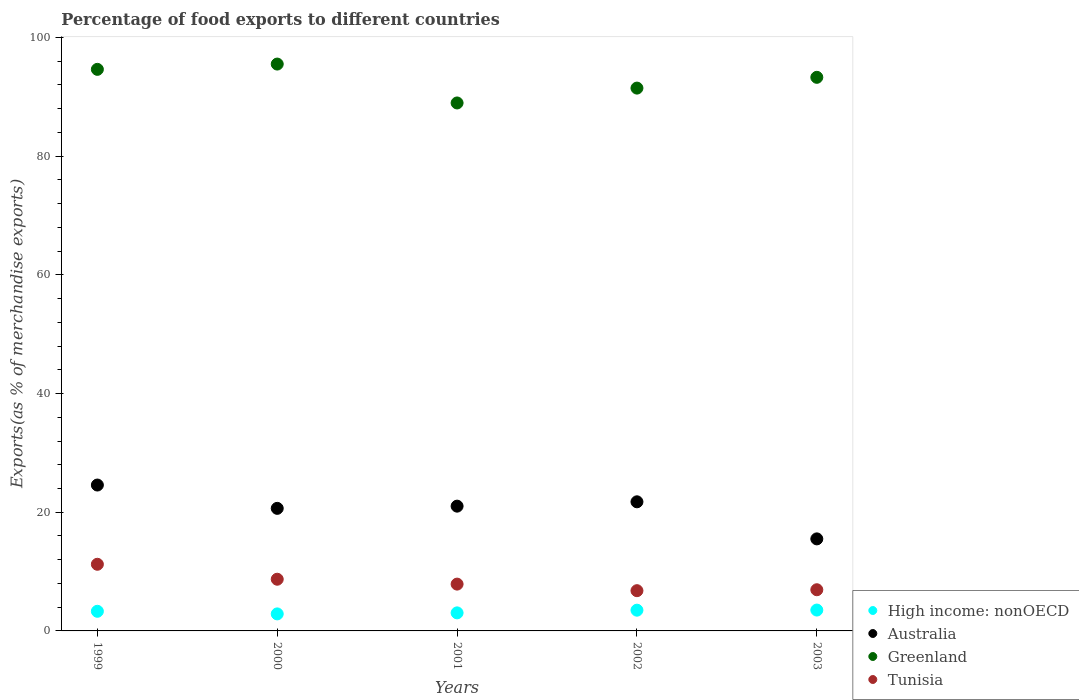How many different coloured dotlines are there?
Your response must be concise. 4. What is the percentage of exports to different countries in Australia in 2003?
Your response must be concise. 15.51. Across all years, what is the maximum percentage of exports to different countries in High income: nonOECD?
Keep it short and to the point. 3.52. Across all years, what is the minimum percentage of exports to different countries in Tunisia?
Ensure brevity in your answer.  6.78. In which year was the percentage of exports to different countries in Greenland maximum?
Provide a short and direct response. 2000. In which year was the percentage of exports to different countries in Tunisia minimum?
Keep it short and to the point. 2002. What is the total percentage of exports to different countries in Tunisia in the graph?
Keep it short and to the point. 41.55. What is the difference between the percentage of exports to different countries in Tunisia in 2000 and that in 2001?
Keep it short and to the point. 0.82. What is the difference between the percentage of exports to different countries in Tunisia in 2001 and the percentage of exports to different countries in Greenland in 2000?
Offer a terse response. -87.63. What is the average percentage of exports to different countries in Australia per year?
Make the answer very short. 20.7. In the year 1999, what is the difference between the percentage of exports to different countries in Greenland and percentage of exports to different countries in High income: nonOECD?
Make the answer very short. 91.31. What is the ratio of the percentage of exports to different countries in High income: nonOECD in 2001 to that in 2003?
Offer a terse response. 0.87. What is the difference between the highest and the second highest percentage of exports to different countries in Tunisia?
Keep it short and to the point. 2.52. What is the difference between the highest and the lowest percentage of exports to different countries in Greenland?
Offer a terse response. 6.55. In how many years, is the percentage of exports to different countries in High income: nonOECD greater than the average percentage of exports to different countries in High income: nonOECD taken over all years?
Make the answer very short. 3. Is it the case that in every year, the sum of the percentage of exports to different countries in Tunisia and percentage of exports to different countries in Greenland  is greater than the sum of percentage of exports to different countries in High income: nonOECD and percentage of exports to different countries in Australia?
Your response must be concise. Yes. Is it the case that in every year, the sum of the percentage of exports to different countries in Tunisia and percentage of exports to different countries in Greenland  is greater than the percentage of exports to different countries in Australia?
Your answer should be compact. Yes. Is the percentage of exports to different countries in High income: nonOECD strictly less than the percentage of exports to different countries in Australia over the years?
Offer a very short reply. Yes. How many years are there in the graph?
Offer a terse response. 5. Are the values on the major ticks of Y-axis written in scientific E-notation?
Ensure brevity in your answer.  No. Does the graph contain grids?
Provide a short and direct response. No. Where does the legend appear in the graph?
Provide a succinct answer. Bottom right. What is the title of the graph?
Your answer should be compact. Percentage of food exports to different countries. Does "Palau" appear as one of the legend labels in the graph?
Your answer should be compact. No. What is the label or title of the X-axis?
Your answer should be very brief. Years. What is the label or title of the Y-axis?
Offer a terse response. Exports(as % of merchandise exports). What is the Exports(as % of merchandise exports) in High income: nonOECD in 1999?
Give a very brief answer. 3.31. What is the Exports(as % of merchandise exports) of Australia in 1999?
Provide a short and direct response. 24.58. What is the Exports(as % of merchandise exports) in Greenland in 1999?
Provide a succinct answer. 94.62. What is the Exports(as % of merchandise exports) in Tunisia in 1999?
Ensure brevity in your answer.  11.23. What is the Exports(as % of merchandise exports) of High income: nonOECD in 2000?
Your answer should be compact. 2.87. What is the Exports(as % of merchandise exports) in Australia in 2000?
Your answer should be very brief. 20.65. What is the Exports(as % of merchandise exports) in Greenland in 2000?
Keep it short and to the point. 95.51. What is the Exports(as % of merchandise exports) of Tunisia in 2000?
Give a very brief answer. 8.71. What is the Exports(as % of merchandise exports) of High income: nonOECD in 2001?
Offer a very short reply. 3.04. What is the Exports(as % of merchandise exports) of Australia in 2001?
Your answer should be very brief. 21.02. What is the Exports(as % of merchandise exports) in Greenland in 2001?
Provide a succinct answer. 88.96. What is the Exports(as % of merchandise exports) in Tunisia in 2001?
Your response must be concise. 7.89. What is the Exports(as % of merchandise exports) in High income: nonOECD in 2002?
Provide a short and direct response. 3.49. What is the Exports(as % of merchandise exports) in Australia in 2002?
Your answer should be very brief. 21.76. What is the Exports(as % of merchandise exports) of Greenland in 2002?
Make the answer very short. 91.46. What is the Exports(as % of merchandise exports) of Tunisia in 2002?
Ensure brevity in your answer.  6.78. What is the Exports(as % of merchandise exports) in High income: nonOECD in 2003?
Give a very brief answer. 3.52. What is the Exports(as % of merchandise exports) of Australia in 2003?
Provide a succinct answer. 15.51. What is the Exports(as % of merchandise exports) of Greenland in 2003?
Give a very brief answer. 93.28. What is the Exports(as % of merchandise exports) in Tunisia in 2003?
Your response must be concise. 6.94. Across all years, what is the maximum Exports(as % of merchandise exports) of High income: nonOECD?
Provide a short and direct response. 3.52. Across all years, what is the maximum Exports(as % of merchandise exports) in Australia?
Offer a terse response. 24.58. Across all years, what is the maximum Exports(as % of merchandise exports) in Greenland?
Your answer should be compact. 95.51. Across all years, what is the maximum Exports(as % of merchandise exports) of Tunisia?
Provide a succinct answer. 11.23. Across all years, what is the minimum Exports(as % of merchandise exports) in High income: nonOECD?
Keep it short and to the point. 2.87. Across all years, what is the minimum Exports(as % of merchandise exports) of Australia?
Your answer should be compact. 15.51. Across all years, what is the minimum Exports(as % of merchandise exports) in Greenland?
Your answer should be very brief. 88.96. Across all years, what is the minimum Exports(as % of merchandise exports) in Tunisia?
Make the answer very short. 6.78. What is the total Exports(as % of merchandise exports) in High income: nonOECD in the graph?
Your answer should be compact. 16.23. What is the total Exports(as % of merchandise exports) of Australia in the graph?
Your response must be concise. 103.52. What is the total Exports(as % of merchandise exports) in Greenland in the graph?
Provide a succinct answer. 463.84. What is the total Exports(as % of merchandise exports) of Tunisia in the graph?
Ensure brevity in your answer.  41.55. What is the difference between the Exports(as % of merchandise exports) in High income: nonOECD in 1999 and that in 2000?
Ensure brevity in your answer.  0.44. What is the difference between the Exports(as % of merchandise exports) of Australia in 1999 and that in 2000?
Your response must be concise. 3.93. What is the difference between the Exports(as % of merchandise exports) of Greenland in 1999 and that in 2000?
Your answer should be compact. -0.89. What is the difference between the Exports(as % of merchandise exports) of Tunisia in 1999 and that in 2000?
Provide a succinct answer. 2.52. What is the difference between the Exports(as % of merchandise exports) in High income: nonOECD in 1999 and that in 2001?
Give a very brief answer. 0.27. What is the difference between the Exports(as % of merchandise exports) in Australia in 1999 and that in 2001?
Your response must be concise. 3.56. What is the difference between the Exports(as % of merchandise exports) in Greenland in 1999 and that in 2001?
Give a very brief answer. 5.66. What is the difference between the Exports(as % of merchandise exports) of Tunisia in 1999 and that in 2001?
Your response must be concise. 3.34. What is the difference between the Exports(as % of merchandise exports) of High income: nonOECD in 1999 and that in 2002?
Your answer should be very brief. -0.19. What is the difference between the Exports(as % of merchandise exports) of Australia in 1999 and that in 2002?
Provide a succinct answer. 2.83. What is the difference between the Exports(as % of merchandise exports) of Greenland in 1999 and that in 2002?
Your response must be concise. 3.16. What is the difference between the Exports(as % of merchandise exports) in Tunisia in 1999 and that in 2002?
Your answer should be very brief. 4.45. What is the difference between the Exports(as % of merchandise exports) in High income: nonOECD in 1999 and that in 2003?
Your response must be concise. -0.21. What is the difference between the Exports(as % of merchandise exports) in Australia in 1999 and that in 2003?
Your response must be concise. 9.07. What is the difference between the Exports(as % of merchandise exports) of Greenland in 1999 and that in 2003?
Offer a terse response. 1.34. What is the difference between the Exports(as % of merchandise exports) of Tunisia in 1999 and that in 2003?
Your response must be concise. 4.29. What is the difference between the Exports(as % of merchandise exports) of High income: nonOECD in 2000 and that in 2001?
Provide a short and direct response. -0.17. What is the difference between the Exports(as % of merchandise exports) of Australia in 2000 and that in 2001?
Provide a short and direct response. -0.37. What is the difference between the Exports(as % of merchandise exports) of Greenland in 2000 and that in 2001?
Ensure brevity in your answer.  6.55. What is the difference between the Exports(as % of merchandise exports) in Tunisia in 2000 and that in 2001?
Provide a short and direct response. 0.82. What is the difference between the Exports(as % of merchandise exports) of High income: nonOECD in 2000 and that in 2002?
Your response must be concise. -0.63. What is the difference between the Exports(as % of merchandise exports) of Australia in 2000 and that in 2002?
Ensure brevity in your answer.  -1.1. What is the difference between the Exports(as % of merchandise exports) in Greenland in 2000 and that in 2002?
Offer a very short reply. 4.05. What is the difference between the Exports(as % of merchandise exports) in Tunisia in 2000 and that in 2002?
Your answer should be compact. 1.93. What is the difference between the Exports(as % of merchandise exports) in High income: nonOECD in 2000 and that in 2003?
Offer a very short reply. -0.65. What is the difference between the Exports(as % of merchandise exports) in Australia in 2000 and that in 2003?
Your answer should be compact. 5.14. What is the difference between the Exports(as % of merchandise exports) in Greenland in 2000 and that in 2003?
Your answer should be compact. 2.23. What is the difference between the Exports(as % of merchandise exports) of Tunisia in 2000 and that in 2003?
Offer a very short reply. 1.77. What is the difference between the Exports(as % of merchandise exports) in High income: nonOECD in 2001 and that in 2002?
Your answer should be very brief. -0.45. What is the difference between the Exports(as % of merchandise exports) of Australia in 2001 and that in 2002?
Keep it short and to the point. -0.73. What is the difference between the Exports(as % of merchandise exports) of Greenland in 2001 and that in 2002?
Offer a terse response. -2.5. What is the difference between the Exports(as % of merchandise exports) of Tunisia in 2001 and that in 2002?
Provide a succinct answer. 1.11. What is the difference between the Exports(as % of merchandise exports) of High income: nonOECD in 2001 and that in 2003?
Ensure brevity in your answer.  -0.47. What is the difference between the Exports(as % of merchandise exports) in Australia in 2001 and that in 2003?
Ensure brevity in your answer.  5.52. What is the difference between the Exports(as % of merchandise exports) of Greenland in 2001 and that in 2003?
Give a very brief answer. -4.32. What is the difference between the Exports(as % of merchandise exports) of Tunisia in 2001 and that in 2003?
Provide a short and direct response. 0.95. What is the difference between the Exports(as % of merchandise exports) in High income: nonOECD in 2002 and that in 2003?
Give a very brief answer. -0.02. What is the difference between the Exports(as % of merchandise exports) of Australia in 2002 and that in 2003?
Provide a short and direct response. 6.25. What is the difference between the Exports(as % of merchandise exports) in Greenland in 2002 and that in 2003?
Make the answer very short. -1.82. What is the difference between the Exports(as % of merchandise exports) in Tunisia in 2002 and that in 2003?
Make the answer very short. -0.16. What is the difference between the Exports(as % of merchandise exports) of High income: nonOECD in 1999 and the Exports(as % of merchandise exports) of Australia in 2000?
Your answer should be compact. -17.34. What is the difference between the Exports(as % of merchandise exports) of High income: nonOECD in 1999 and the Exports(as % of merchandise exports) of Greenland in 2000?
Your response must be concise. -92.21. What is the difference between the Exports(as % of merchandise exports) in High income: nonOECD in 1999 and the Exports(as % of merchandise exports) in Tunisia in 2000?
Offer a very short reply. -5.4. What is the difference between the Exports(as % of merchandise exports) in Australia in 1999 and the Exports(as % of merchandise exports) in Greenland in 2000?
Keep it short and to the point. -70.93. What is the difference between the Exports(as % of merchandise exports) in Australia in 1999 and the Exports(as % of merchandise exports) in Tunisia in 2000?
Offer a terse response. 15.87. What is the difference between the Exports(as % of merchandise exports) in Greenland in 1999 and the Exports(as % of merchandise exports) in Tunisia in 2000?
Ensure brevity in your answer.  85.91. What is the difference between the Exports(as % of merchandise exports) of High income: nonOECD in 1999 and the Exports(as % of merchandise exports) of Australia in 2001?
Your answer should be compact. -17.72. What is the difference between the Exports(as % of merchandise exports) in High income: nonOECD in 1999 and the Exports(as % of merchandise exports) in Greenland in 2001?
Ensure brevity in your answer.  -85.65. What is the difference between the Exports(as % of merchandise exports) of High income: nonOECD in 1999 and the Exports(as % of merchandise exports) of Tunisia in 2001?
Make the answer very short. -4.58. What is the difference between the Exports(as % of merchandise exports) in Australia in 1999 and the Exports(as % of merchandise exports) in Greenland in 2001?
Your response must be concise. -64.38. What is the difference between the Exports(as % of merchandise exports) of Australia in 1999 and the Exports(as % of merchandise exports) of Tunisia in 2001?
Ensure brevity in your answer.  16.69. What is the difference between the Exports(as % of merchandise exports) in Greenland in 1999 and the Exports(as % of merchandise exports) in Tunisia in 2001?
Give a very brief answer. 86.74. What is the difference between the Exports(as % of merchandise exports) of High income: nonOECD in 1999 and the Exports(as % of merchandise exports) of Australia in 2002?
Ensure brevity in your answer.  -18.45. What is the difference between the Exports(as % of merchandise exports) in High income: nonOECD in 1999 and the Exports(as % of merchandise exports) in Greenland in 2002?
Your response must be concise. -88.16. What is the difference between the Exports(as % of merchandise exports) of High income: nonOECD in 1999 and the Exports(as % of merchandise exports) of Tunisia in 2002?
Offer a terse response. -3.47. What is the difference between the Exports(as % of merchandise exports) in Australia in 1999 and the Exports(as % of merchandise exports) in Greenland in 2002?
Your answer should be very brief. -66.88. What is the difference between the Exports(as % of merchandise exports) of Australia in 1999 and the Exports(as % of merchandise exports) of Tunisia in 2002?
Provide a succinct answer. 17.8. What is the difference between the Exports(as % of merchandise exports) of Greenland in 1999 and the Exports(as % of merchandise exports) of Tunisia in 2002?
Provide a succinct answer. 87.84. What is the difference between the Exports(as % of merchandise exports) in High income: nonOECD in 1999 and the Exports(as % of merchandise exports) in Australia in 2003?
Provide a short and direct response. -12.2. What is the difference between the Exports(as % of merchandise exports) of High income: nonOECD in 1999 and the Exports(as % of merchandise exports) of Greenland in 2003?
Ensure brevity in your answer.  -89.97. What is the difference between the Exports(as % of merchandise exports) of High income: nonOECD in 1999 and the Exports(as % of merchandise exports) of Tunisia in 2003?
Offer a very short reply. -3.63. What is the difference between the Exports(as % of merchandise exports) of Australia in 1999 and the Exports(as % of merchandise exports) of Greenland in 2003?
Keep it short and to the point. -68.7. What is the difference between the Exports(as % of merchandise exports) of Australia in 1999 and the Exports(as % of merchandise exports) of Tunisia in 2003?
Offer a terse response. 17.64. What is the difference between the Exports(as % of merchandise exports) of Greenland in 1999 and the Exports(as % of merchandise exports) of Tunisia in 2003?
Your response must be concise. 87.68. What is the difference between the Exports(as % of merchandise exports) of High income: nonOECD in 2000 and the Exports(as % of merchandise exports) of Australia in 2001?
Your answer should be very brief. -18.16. What is the difference between the Exports(as % of merchandise exports) of High income: nonOECD in 2000 and the Exports(as % of merchandise exports) of Greenland in 2001?
Your answer should be compact. -86.09. What is the difference between the Exports(as % of merchandise exports) of High income: nonOECD in 2000 and the Exports(as % of merchandise exports) of Tunisia in 2001?
Your response must be concise. -5.02. What is the difference between the Exports(as % of merchandise exports) in Australia in 2000 and the Exports(as % of merchandise exports) in Greenland in 2001?
Give a very brief answer. -68.31. What is the difference between the Exports(as % of merchandise exports) in Australia in 2000 and the Exports(as % of merchandise exports) in Tunisia in 2001?
Ensure brevity in your answer.  12.76. What is the difference between the Exports(as % of merchandise exports) in Greenland in 2000 and the Exports(as % of merchandise exports) in Tunisia in 2001?
Give a very brief answer. 87.63. What is the difference between the Exports(as % of merchandise exports) in High income: nonOECD in 2000 and the Exports(as % of merchandise exports) in Australia in 2002?
Make the answer very short. -18.89. What is the difference between the Exports(as % of merchandise exports) in High income: nonOECD in 2000 and the Exports(as % of merchandise exports) in Greenland in 2002?
Your answer should be compact. -88.6. What is the difference between the Exports(as % of merchandise exports) in High income: nonOECD in 2000 and the Exports(as % of merchandise exports) in Tunisia in 2002?
Provide a short and direct response. -3.91. What is the difference between the Exports(as % of merchandise exports) in Australia in 2000 and the Exports(as % of merchandise exports) in Greenland in 2002?
Provide a short and direct response. -70.81. What is the difference between the Exports(as % of merchandise exports) in Australia in 2000 and the Exports(as % of merchandise exports) in Tunisia in 2002?
Offer a terse response. 13.87. What is the difference between the Exports(as % of merchandise exports) in Greenland in 2000 and the Exports(as % of merchandise exports) in Tunisia in 2002?
Keep it short and to the point. 88.73. What is the difference between the Exports(as % of merchandise exports) of High income: nonOECD in 2000 and the Exports(as % of merchandise exports) of Australia in 2003?
Your response must be concise. -12.64. What is the difference between the Exports(as % of merchandise exports) in High income: nonOECD in 2000 and the Exports(as % of merchandise exports) in Greenland in 2003?
Offer a very short reply. -90.41. What is the difference between the Exports(as % of merchandise exports) of High income: nonOECD in 2000 and the Exports(as % of merchandise exports) of Tunisia in 2003?
Your response must be concise. -4.07. What is the difference between the Exports(as % of merchandise exports) in Australia in 2000 and the Exports(as % of merchandise exports) in Greenland in 2003?
Offer a very short reply. -72.63. What is the difference between the Exports(as % of merchandise exports) in Australia in 2000 and the Exports(as % of merchandise exports) in Tunisia in 2003?
Your response must be concise. 13.71. What is the difference between the Exports(as % of merchandise exports) of Greenland in 2000 and the Exports(as % of merchandise exports) of Tunisia in 2003?
Ensure brevity in your answer.  88.58. What is the difference between the Exports(as % of merchandise exports) of High income: nonOECD in 2001 and the Exports(as % of merchandise exports) of Australia in 2002?
Your answer should be compact. -18.71. What is the difference between the Exports(as % of merchandise exports) of High income: nonOECD in 2001 and the Exports(as % of merchandise exports) of Greenland in 2002?
Offer a terse response. -88.42. What is the difference between the Exports(as % of merchandise exports) of High income: nonOECD in 2001 and the Exports(as % of merchandise exports) of Tunisia in 2002?
Offer a terse response. -3.74. What is the difference between the Exports(as % of merchandise exports) in Australia in 2001 and the Exports(as % of merchandise exports) in Greenland in 2002?
Provide a short and direct response. -70.44. What is the difference between the Exports(as % of merchandise exports) in Australia in 2001 and the Exports(as % of merchandise exports) in Tunisia in 2002?
Your response must be concise. 14.24. What is the difference between the Exports(as % of merchandise exports) of Greenland in 2001 and the Exports(as % of merchandise exports) of Tunisia in 2002?
Keep it short and to the point. 82.18. What is the difference between the Exports(as % of merchandise exports) in High income: nonOECD in 2001 and the Exports(as % of merchandise exports) in Australia in 2003?
Make the answer very short. -12.47. What is the difference between the Exports(as % of merchandise exports) of High income: nonOECD in 2001 and the Exports(as % of merchandise exports) of Greenland in 2003?
Offer a terse response. -90.24. What is the difference between the Exports(as % of merchandise exports) in High income: nonOECD in 2001 and the Exports(as % of merchandise exports) in Tunisia in 2003?
Keep it short and to the point. -3.9. What is the difference between the Exports(as % of merchandise exports) in Australia in 2001 and the Exports(as % of merchandise exports) in Greenland in 2003?
Provide a short and direct response. -72.26. What is the difference between the Exports(as % of merchandise exports) of Australia in 2001 and the Exports(as % of merchandise exports) of Tunisia in 2003?
Offer a very short reply. 14.09. What is the difference between the Exports(as % of merchandise exports) of Greenland in 2001 and the Exports(as % of merchandise exports) of Tunisia in 2003?
Provide a short and direct response. 82.02. What is the difference between the Exports(as % of merchandise exports) in High income: nonOECD in 2002 and the Exports(as % of merchandise exports) in Australia in 2003?
Your answer should be very brief. -12.01. What is the difference between the Exports(as % of merchandise exports) of High income: nonOECD in 2002 and the Exports(as % of merchandise exports) of Greenland in 2003?
Your answer should be compact. -89.79. What is the difference between the Exports(as % of merchandise exports) in High income: nonOECD in 2002 and the Exports(as % of merchandise exports) in Tunisia in 2003?
Ensure brevity in your answer.  -3.44. What is the difference between the Exports(as % of merchandise exports) of Australia in 2002 and the Exports(as % of merchandise exports) of Greenland in 2003?
Your answer should be compact. -71.53. What is the difference between the Exports(as % of merchandise exports) of Australia in 2002 and the Exports(as % of merchandise exports) of Tunisia in 2003?
Provide a succinct answer. 14.82. What is the difference between the Exports(as % of merchandise exports) of Greenland in 2002 and the Exports(as % of merchandise exports) of Tunisia in 2003?
Offer a very short reply. 84.53. What is the average Exports(as % of merchandise exports) of High income: nonOECD per year?
Your answer should be very brief. 3.25. What is the average Exports(as % of merchandise exports) of Australia per year?
Provide a short and direct response. 20.7. What is the average Exports(as % of merchandise exports) of Greenland per year?
Offer a terse response. 92.77. What is the average Exports(as % of merchandise exports) of Tunisia per year?
Keep it short and to the point. 8.31. In the year 1999, what is the difference between the Exports(as % of merchandise exports) in High income: nonOECD and Exports(as % of merchandise exports) in Australia?
Give a very brief answer. -21.27. In the year 1999, what is the difference between the Exports(as % of merchandise exports) of High income: nonOECD and Exports(as % of merchandise exports) of Greenland?
Give a very brief answer. -91.31. In the year 1999, what is the difference between the Exports(as % of merchandise exports) in High income: nonOECD and Exports(as % of merchandise exports) in Tunisia?
Your response must be concise. -7.92. In the year 1999, what is the difference between the Exports(as % of merchandise exports) of Australia and Exports(as % of merchandise exports) of Greenland?
Your response must be concise. -70.04. In the year 1999, what is the difference between the Exports(as % of merchandise exports) in Australia and Exports(as % of merchandise exports) in Tunisia?
Offer a very short reply. 13.35. In the year 1999, what is the difference between the Exports(as % of merchandise exports) of Greenland and Exports(as % of merchandise exports) of Tunisia?
Your response must be concise. 83.39. In the year 2000, what is the difference between the Exports(as % of merchandise exports) in High income: nonOECD and Exports(as % of merchandise exports) in Australia?
Provide a succinct answer. -17.78. In the year 2000, what is the difference between the Exports(as % of merchandise exports) in High income: nonOECD and Exports(as % of merchandise exports) in Greenland?
Offer a terse response. -92.65. In the year 2000, what is the difference between the Exports(as % of merchandise exports) of High income: nonOECD and Exports(as % of merchandise exports) of Tunisia?
Give a very brief answer. -5.84. In the year 2000, what is the difference between the Exports(as % of merchandise exports) in Australia and Exports(as % of merchandise exports) in Greenland?
Offer a terse response. -74.86. In the year 2000, what is the difference between the Exports(as % of merchandise exports) in Australia and Exports(as % of merchandise exports) in Tunisia?
Provide a short and direct response. 11.94. In the year 2000, what is the difference between the Exports(as % of merchandise exports) of Greenland and Exports(as % of merchandise exports) of Tunisia?
Offer a very short reply. 86.8. In the year 2001, what is the difference between the Exports(as % of merchandise exports) of High income: nonOECD and Exports(as % of merchandise exports) of Australia?
Ensure brevity in your answer.  -17.98. In the year 2001, what is the difference between the Exports(as % of merchandise exports) in High income: nonOECD and Exports(as % of merchandise exports) in Greenland?
Offer a terse response. -85.92. In the year 2001, what is the difference between the Exports(as % of merchandise exports) in High income: nonOECD and Exports(as % of merchandise exports) in Tunisia?
Ensure brevity in your answer.  -4.85. In the year 2001, what is the difference between the Exports(as % of merchandise exports) in Australia and Exports(as % of merchandise exports) in Greenland?
Your answer should be very brief. -67.94. In the year 2001, what is the difference between the Exports(as % of merchandise exports) of Australia and Exports(as % of merchandise exports) of Tunisia?
Ensure brevity in your answer.  13.14. In the year 2001, what is the difference between the Exports(as % of merchandise exports) in Greenland and Exports(as % of merchandise exports) in Tunisia?
Your answer should be compact. 81.07. In the year 2002, what is the difference between the Exports(as % of merchandise exports) in High income: nonOECD and Exports(as % of merchandise exports) in Australia?
Offer a terse response. -18.26. In the year 2002, what is the difference between the Exports(as % of merchandise exports) of High income: nonOECD and Exports(as % of merchandise exports) of Greenland?
Give a very brief answer. -87.97. In the year 2002, what is the difference between the Exports(as % of merchandise exports) in High income: nonOECD and Exports(as % of merchandise exports) in Tunisia?
Your answer should be compact. -3.29. In the year 2002, what is the difference between the Exports(as % of merchandise exports) of Australia and Exports(as % of merchandise exports) of Greenland?
Keep it short and to the point. -69.71. In the year 2002, what is the difference between the Exports(as % of merchandise exports) in Australia and Exports(as % of merchandise exports) in Tunisia?
Provide a succinct answer. 14.98. In the year 2002, what is the difference between the Exports(as % of merchandise exports) of Greenland and Exports(as % of merchandise exports) of Tunisia?
Your answer should be compact. 84.68. In the year 2003, what is the difference between the Exports(as % of merchandise exports) in High income: nonOECD and Exports(as % of merchandise exports) in Australia?
Your response must be concise. -11.99. In the year 2003, what is the difference between the Exports(as % of merchandise exports) in High income: nonOECD and Exports(as % of merchandise exports) in Greenland?
Ensure brevity in your answer.  -89.77. In the year 2003, what is the difference between the Exports(as % of merchandise exports) of High income: nonOECD and Exports(as % of merchandise exports) of Tunisia?
Offer a terse response. -3.42. In the year 2003, what is the difference between the Exports(as % of merchandise exports) in Australia and Exports(as % of merchandise exports) in Greenland?
Offer a very short reply. -77.77. In the year 2003, what is the difference between the Exports(as % of merchandise exports) of Australia and Exports(as % of merchandise exports) of Tunisia?
Offer a terse response. 8.57. In the year 2003, what is the difference between the Exports(as % of merchandise exports) in Greenland and Exports(as % of merchandise exports) in Tunisia?
Keep it short and to the point. 86.34. What is the ratio of the Exports(as % of merchandise exports) in High income: nonOECD in 1999 to that in 2000?
Your answer should be compact. 1.15. What is the ratio of the Exports(as % of merchandise exports) in Australia in 1999 to that in 2000?
Offer a terse response. 1.19. What is the ratio of the Exports(as % of merchandise exports) in Greenland in 1999 to that in 2000?
Make the answer very short. 0.99. What is the ratio of the Exports(as % of merchandise exports) in Tunisia in 1999 to that in 2000?
Give a very brief answer. 1.29. What is the ratio of the Exports(as % of merchandise exports) in High income: nonOECD in 1999 to that in 2001?
Your response must be concise. 1.09. What is the ratio of the Exports(as % of merchandise exports) in Australia in 1999 to that in 2001?
Provide a succinct answer. 1.17. What is the ratio of the Exports(as % of merchandise exports) in Greenland in 1999 to that in 2001?
Keep it short and to the point. 1.06. What is the ratio of the Exports(as % of merchandise exports) of Tunisia in 1999 to that in 2001?
Offer a terse response. 1.42. What is the ratio of the Exports(as % of merchandise exports) in High income: nonOECD in 1999 to that in 2002?
Keep it short and to the point. 0.95. What is the ratio of the Exports(as % of merchandise exports) of Australia in 1999 to that in 2002?
Your response must be concise. 1.13. What is the ratio of the Exports(as % of merchandise exports) of Greenland in 1999 to that in 2002?
Your answer should be compact. 1.03. What is the ratio of the Exports(as % of merchandise exports) of Tunisia in 1999 to that in 2002?
Your response must be concise. 1.66. What is the ratio of the Exports(as % of merchandise exports) in High income: nonOECD in 1999 to that in 2003?
Give a very brief answer. 0.94. What is the ratio of the Exports(as % of merchandise exports) in Australia in 1999 to that in 2003?
Give a very brief answer. 1.59. What is the ratio of the Exports(as % of merchandise exports) in Greenland in 1999 to that in 2003?
Give a very brief answer. 1.01. What is the ratio of the Exports(as % of merchandise exports) of Tunisia in 1999 to that in 2003?
Provide a succinct answer. 1.62. What is the ratio of the Exports(as % of merchandise exports) of High income: nonOECD in 2000 to that in 2001?
Provide a succinct answer. 0.94. What is the ratio of the Exports(as % of merchandise exports) of Australia in 2000 to that in 2001?
Give a very brief answer. 0.98. What is the ratio of the Exports(as % of merchandise exports) in Greenland in 2000 to that in 2001?
Offer a very short reply. 1.07. What is the ratio of the Exports(as % of merchandise exports) of Tunisia in 2000 to that in 2001?
Provide a short and direct response. 1.1. What is the ratio of the Exports(as % of merchandise exports) in High income: nonOECD in 2000 to that in 2002?
Offer a very short reply. 0.82. What is the ratio of the Exports(as % of merchandise exports) of Australia in 2000 to that in 2002?
Give a very brief answer. 0.95. What is the ratio of the Exports(as % of merchandise exports) of Greenland in 2000 to that in 2002?
Give a very brief answer. 1.04. What is the ratio of the Exports(as % of merchandise exports) in Tunisia in 2000 to that in 2002?
Keep it short and to the point. 1.28. What is the ratio of the Exports(as % of merchandise exports) of High income: nonOECD in 2000 to that in 2003?
Your response must be concise. 0.82. What is the ratio of the Exports(as % of merchandise exports) in Australia in 2000 to that in 2003?
Provide a short and direct response. 1.33. What is the ratio of the Exports(as % of merchandise exports) in Greenland in 2000 to that in 2003?
Provide a short and direct response. 1.02. What is the ratio of the Exports(as % of merchandise exports) in Tunisia in 2000 to that in 2003?
Offer a terse response. 1.26. What is the ratio of the Exports(as % of merchandise exports) in High income: nonOECD in 2001 to that in 2002?
Offer a terse response. 0.87. What is the ratio of the Exports(as % of merchandise exports) in Australia in 2001 to that in 2002?
Provide a succinct answer. 0.97. What is the ratio of the Exports(as % of merchandise exports) of Greenland in 2001 to that in 2002?
Provide a short and direct response. 0.97. What is the ratio of the Exports(as % of merchandise exports) of Tunisia in 2001 to that in 2002?
Offer a very short reply. 1.16. What is the ratio of the Exports(as % of merchandise exports) in High income: nonOECD in 2001 to that in 2003?
Offer a very short reply. 0.86. What is the ratio of the Exports(as % of merchandise exports) of Australia in 2001 to that in 2003?
Offer a very short reply. 1.36. What is the ratio of the Exports(as % of merchandise exports) of Greenland in 2001 to that in 2003?
Your answer should be very brief. 0.95. What is the ratio of the Exports(as % of merchandise exports) in Tunisia in 2001 to that in 2003?
Your answer should be very brief. 1.14. What is the ratio of the Exports(as % of merchandise exports) of Australia in 2002 to that in 2003?
Your response must be concise. 1.4. What is the ratio of the Exports(as % of merchandise exports) in Greenland in 2002 to that in 2003?
Your response must be concise. 0.98. What is the ratio of the Exports(as % of merchandise exports) of Tunisia in 2002 to that in 2003?
Make the answer very short. 0.98. What is the difference between the highest and the second highest Exports(as % of merchandise exports) in High income: nonOECD?
Your response must be concise. 0.02. What is the difference between the highest and the second highest Exports(as % of merchandise exports) in Australia?
Make the answer very short. 2.83. What is the difference between the highest and the second highest Exports(as % of merchandise exports) in Greenland?
Ensure brevity in your answer.  0.89. What is the difference between the highest and the second highest Exports(as % of merchandise exports) of Tunisia?
Ensure brevity in your answer.  2.52. What is the difference between the highest and the lowest Exports(as % of merchandise exports) of High income: nonOECD?
Keep it short and to the point. 0.65. What is the difference between the highest and the lowest Exports(as % of merchandise exports) in Australia?
Give a very brief answer. 9.07. What is the difference between the highest and the lowest Exports(as % of merchandise exports) in Greenland?
Give a very brief answer. 6.55. What is the difference between the highest and the lowest Exports(as % of merchandise exports) in Tunisia?
Give a very brief answer. 4.45. 